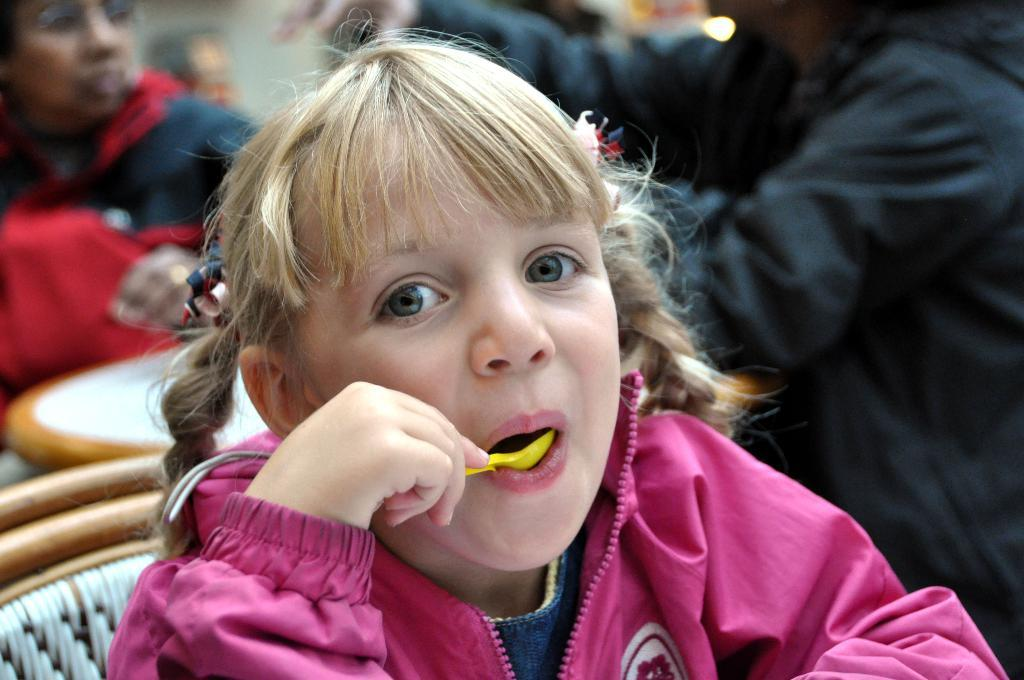What is the girl doing in the image? The girl is sitting and eating in the image. How many people are sitting in the image? There are two persons sitting in the image. What is present for them to eat on? There is a table in the image. What can be seen behind the people in the image? There is a wall visible in the image. What type of alley can be seen behind the girl in the image? There is no alley visible in the image; it only shows a wall behind the girl. 